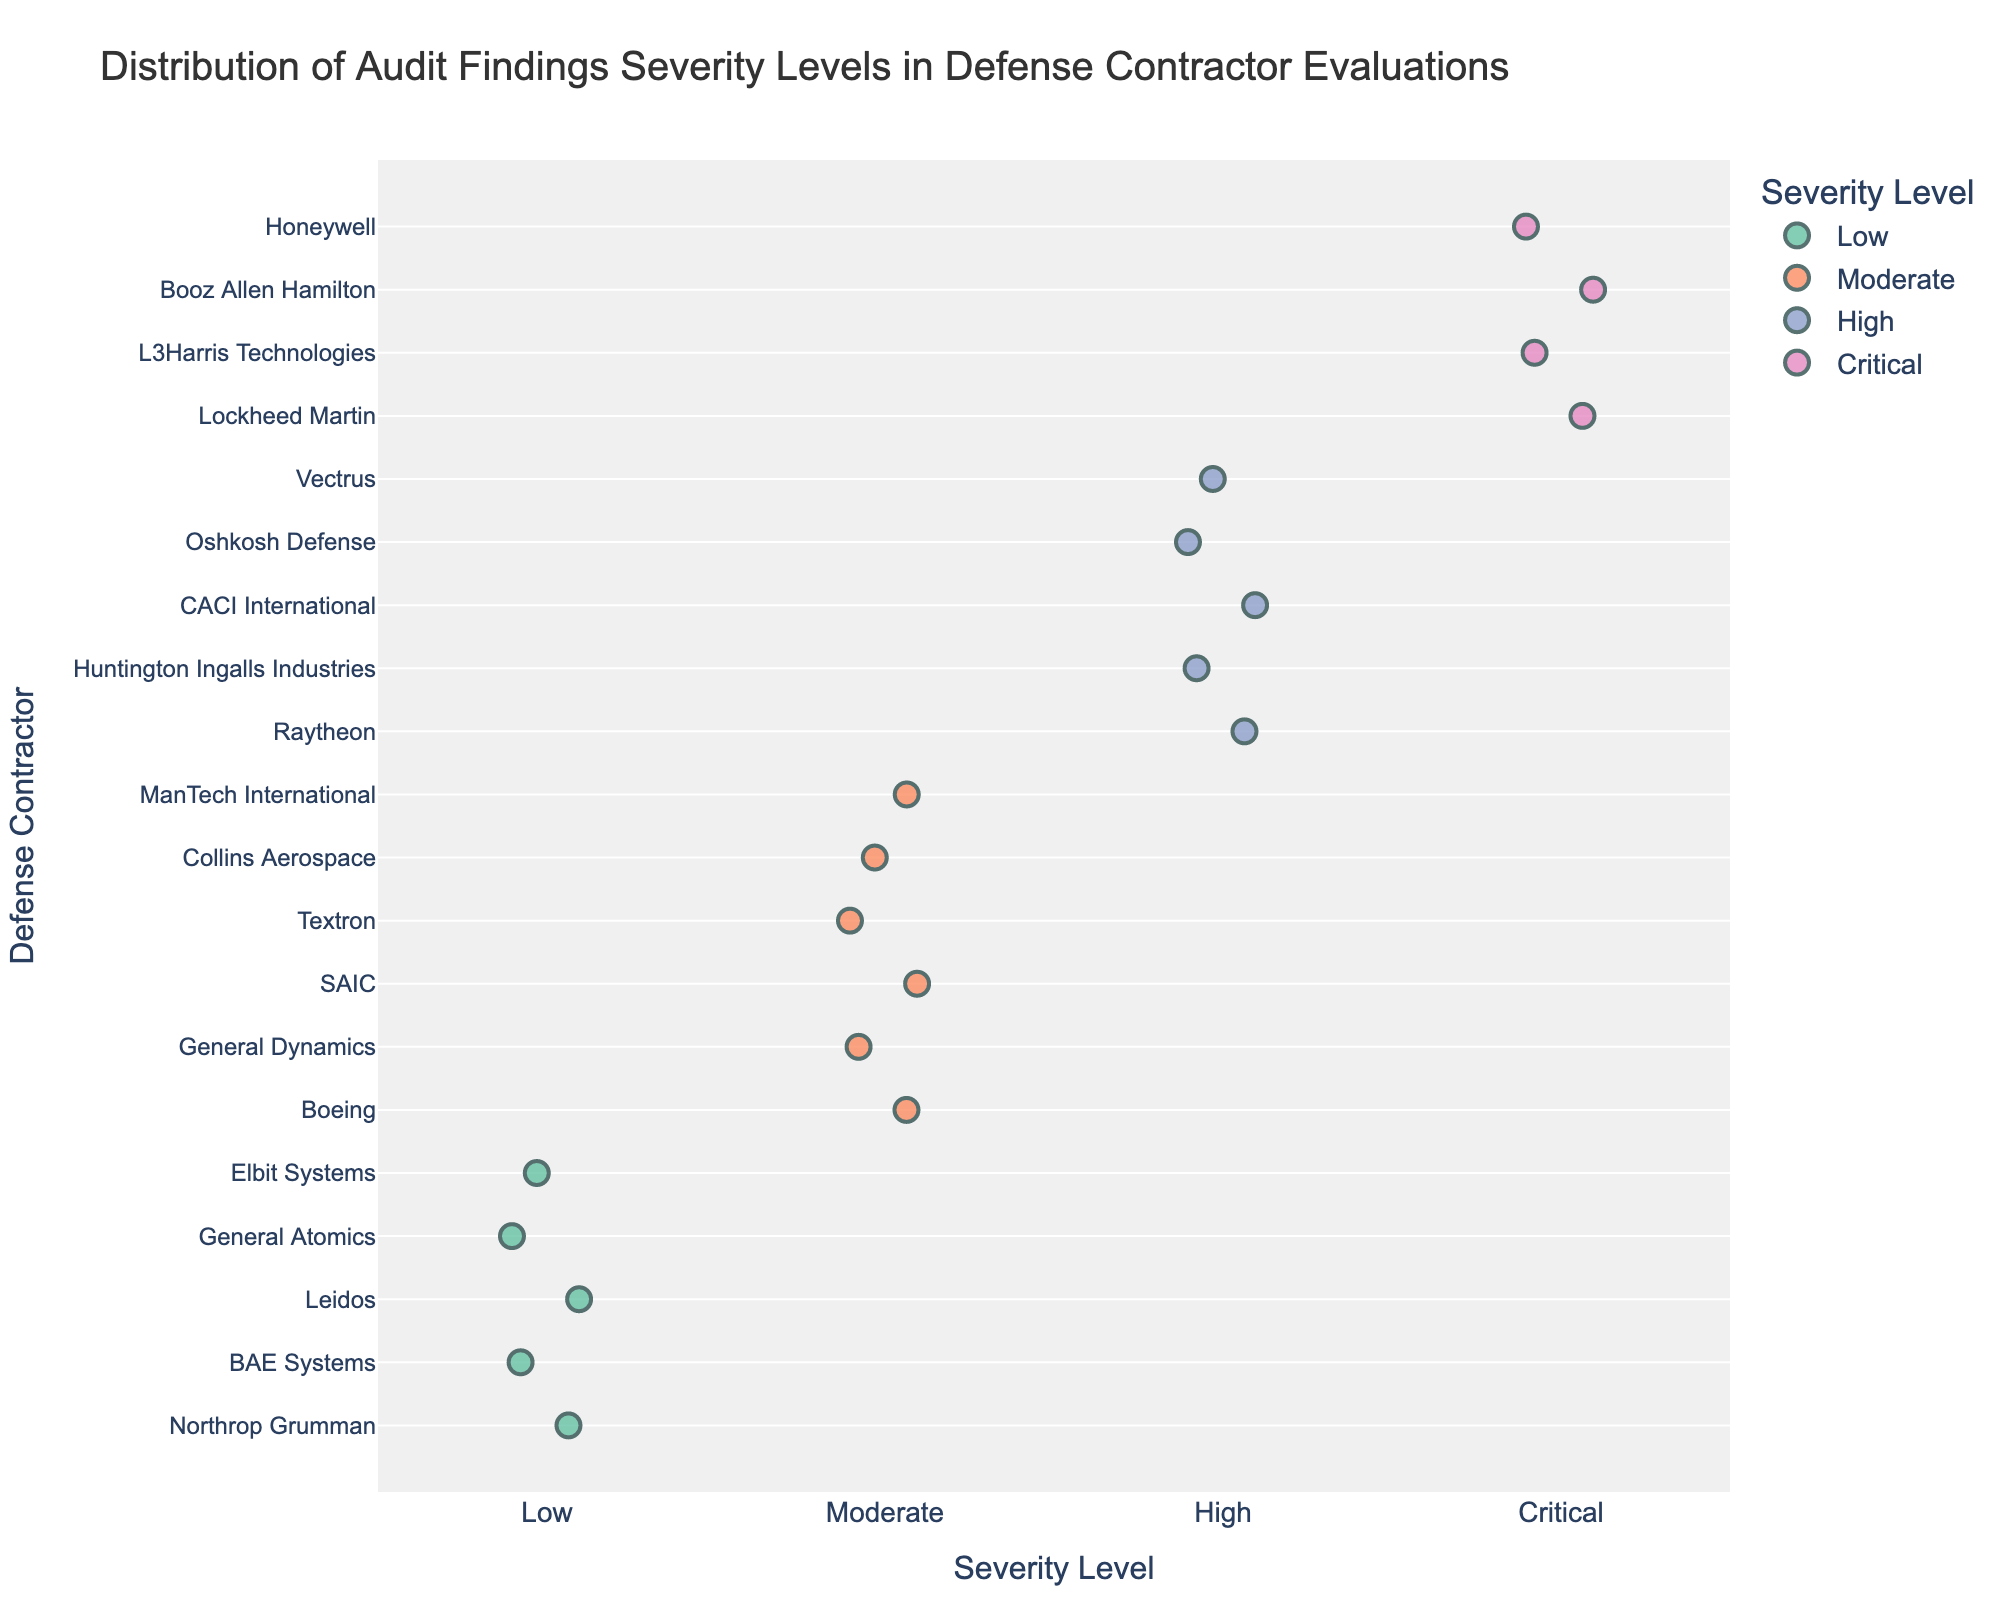What is the title of the figure? The title is located at the top of the figure. It helps in understanding the main subject of the plot.
Answer: Distribution of Audit Findings Severity Levels in Defense Contractor Evaluations What does the x-axis represent? The x-axis represents different levels of audit severity. These categories help in understanding how different contractors are evaluated according to the severity of their audit findings.
Answer: Severity Level Which contractor has been evaluated with a "Critical" severity level? By looking at the "Critical" severity level on the x-axis and identifying the corresponding contractors on the y-axis, we can see which contractors fall under this category.
Answer: Lockheed Martin, L3Harris Technologies, Booz Allen Hamilton, Honeywell How many contractors have been evaluated with a "Moderate" severity level? We count the number of data points aligned with the "Moderate" severity level on the x-axis.
Answer: 6 Which severity level has the fewest contractors evaluated under it? By comparing the number of data points for each severity level, we identify the one with the smallest count.
Answer: Low Who are the contractors with a "High" severity level? Examine the data points aligned with the "High" severity level and read the corresponding labels on the y-axis.
Answer: Raytheon, Huntington Ingalls Industries, CACI International, Oshkosh Defense, Vectrus What is the most common severity level among the contractors? Identify the severity level that has the most data points by visually counting the markers under each category.
Answer: Moderate What is the average number of contractors across all severity levels? Add the number of contractors for each severity level and then divide by the number of levels (4).
Answer: (4 + 6 + 5 + 5) / 4 = 5 Which severity level has the highest number of contractors? By counting the number of data points aligned with each severity level on the x-axis, we identify the severity level with the most markers.
Answer: Moderate How are the colors used in the figure? The colors differentiate between the different severity levels of audit findings, helping to quickly identify the category associated with each contractor.
Answer: Low: greenish-blue, Moderate: orange, High: blue, Critical: pink 